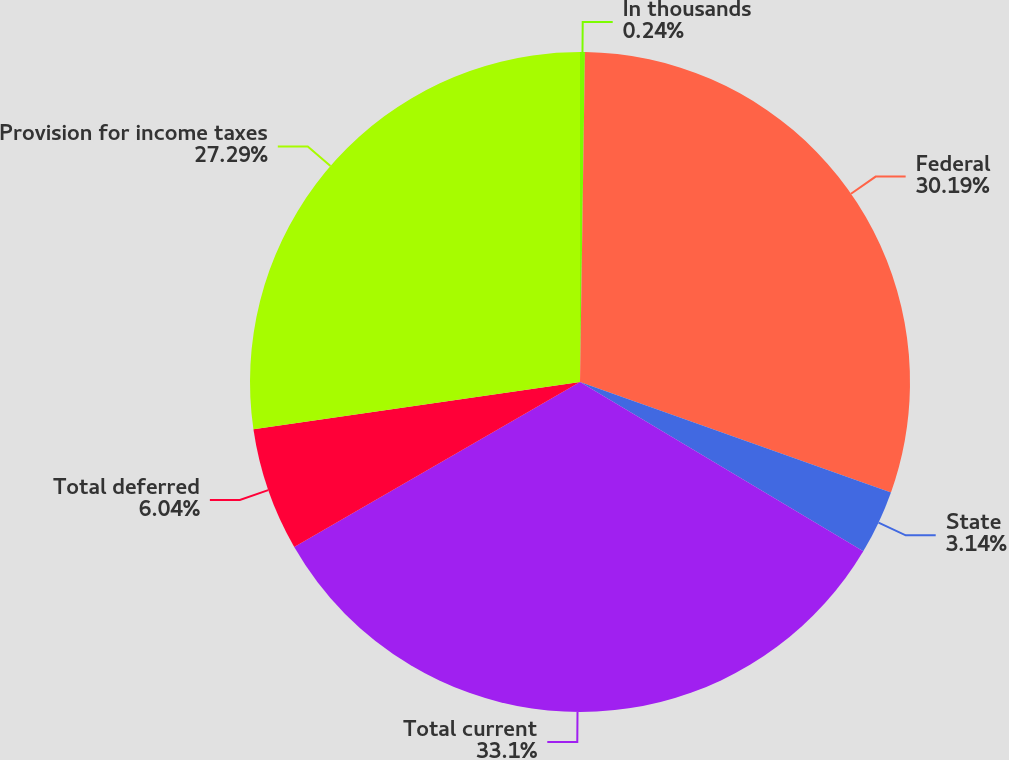Convert chart to OTSL. <chart><loc_0><loc_0><loc_500><loc_500><pie_chart><fcel>In thousands<fcel>Federal<fcel>State<fcel>Total current<fcel>Total deferred<fcel>Provision for income taxes<nl><fcel>0.24%<fcel>30.19%<fcel>3.14%<fcel>33.09%<fcel>6.04%<fcel>27.29%<nl></chart> 